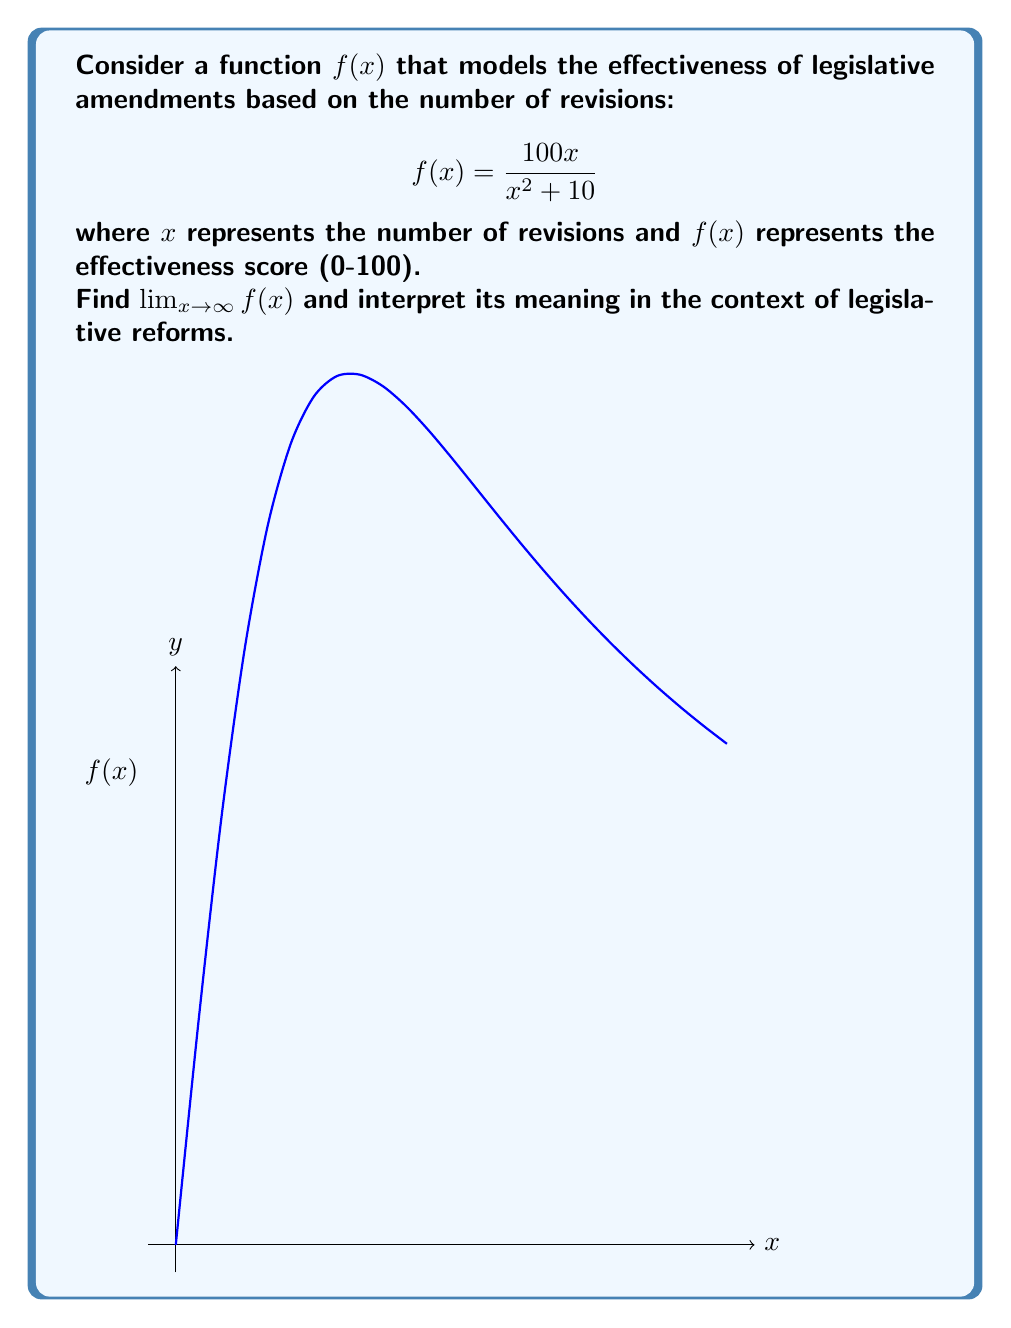Can you solve this math problem? To find $\lim_{x \to \infty} f(x)$, we follow these steps:

1) First, let's examine the function:
   $$f(x) = \frac{100x}{x^2 + 10}$$

2) As $x$ approaches infinity, both numerator and denominator grow, but the denominator grows faster. We can analyze this by dividing both top and bottom by the highest power of x in the denominator:

   $$\lim_{x \to \infty} f(x) = \lim_{x \to \infty} \frac{100x}{x^2 + 10}$$
   $$= \lim_{x \to \infty} \frac{100x/x^2}{(x^2 + 10)/x^2}$$
   $$= \lim_{x \to \infty} \frac{100/x}{1 + 10/x^2}$$

3) As $x$ approaches infinity, $1/x$ and $1/x^2$ approach 0:

   $$\lim_{x \to \infty} \frac{100/x}{1 + 10/x^2} = \frac{0}{1 + 0} = 0$$

4) Interpretation: As the number of revisions (x) increases indefinitely, the effectiveness of legislative amendments approaches 0. This suggests that excessive revisions may lead to diminishing returns in terms of amendment effectiveness.
Answer: $\lim_{x \to \infty} f(x) = 0$ 